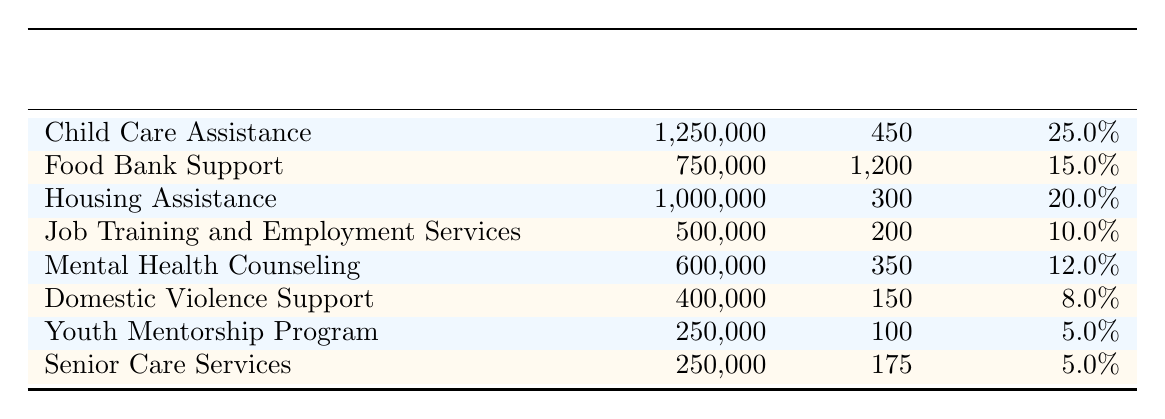What is the annual budget allocation for the Food Bank Support program? The table lists the Food Bank Support program with an annual budget allocation of $750,000.
Answer: $750,000 How many families are served by the Child Care Assistance program? The table indicates that the Child Care Assistance program serves 450 families.
Answer: 450 Which program has the highest percentage of the total budget? According to the table, Child Care Assistance has the highest percentage of the total budget at 25.0%.
Answer: 25.0% What is the total annual budget allocated to all programs? To find the total, we sum the annual budget allocations: 1,250,000 + 750,000 + 1,000,000 + 500,000 + 600,000 + 400,000 + 250,000 + 250,000 = 5,000,000.
Answer: $5,000,000 How many more families are served by the Food Bank Support program compared to the Domestic Violence Support program? The Food Bank Support program serves 1,200 families, while the Domestic Violence Support program serves 150 families. The difference is 1,200 - 150 = 1,050.
Answer: 1,050 What percentage of the total budget is allocated to Job Training and Employment Services? The percentage allocated to Job Training and Employment Services is given as 10.0% in the table.
Answer: 10.0% If you combine the budget allocations for Senior Care Services and Youth Mentorship Program, what is the total? The budget for Senior Care Services is $250,000 and for Youth Mentorship Program is $250,000. Adding these gives 250,000 + 250,000 = 500,000.
Answer: $500,000 Is the budget allocation for Mental Health Counseling greater than that for Domestic Violence Support? The table shows that Mental Health Counseling has a budget allocation of $600,000, which is greater than Domestic Violence Support's allocation of $400,000.
Answer: Yes What is the average number of families served by the programs listed? First, we find the total number of families served: 450 + 1200 + 300 + 200 + 350 + 150 + 100 + 175 = 3025. There are 8 programs, so the average is 3025/8 = 378.125, which can be rounded to 378.
Answer: 378 Which program serves the least number of families? By examining the table, the Youth Mentorship Program serves the least number of families at 100.
Answer: Youth Mentorship Program 